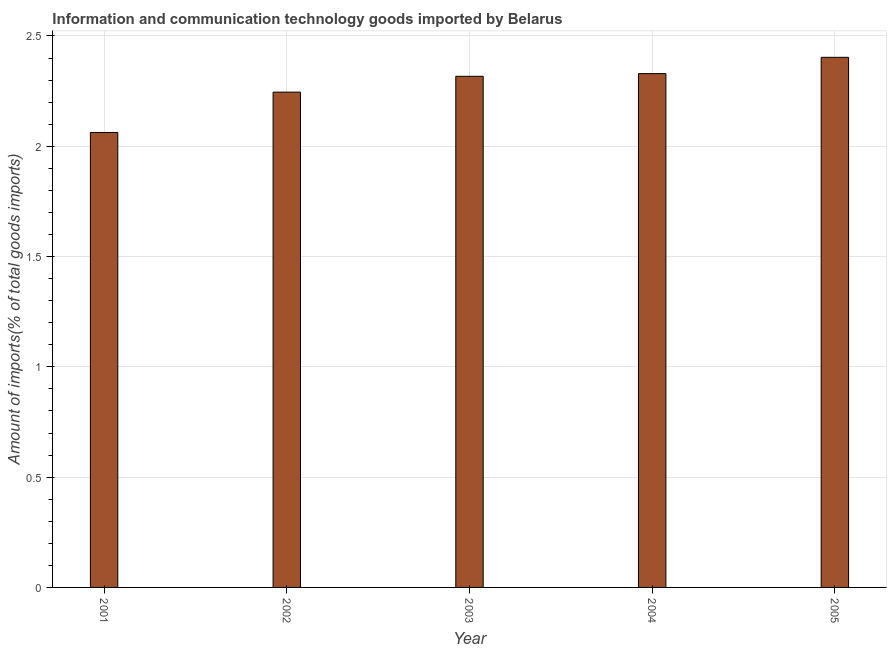Does the graph contain any zero values?
Make the answer very short. No. What is the title of the graph?
Your response must be concise. Information and communication technology goods imported by Belarus. What is the label or title of the X-axis?
Provide a succinct answer. Year. What is the label or title of the Y-axis?
Provide a short and direct response. Amount of imports(% of total goods imports). What is the amount of ict goods imports in 2003?
Offer a very short reply. 2.32. Across all years, what is the maximum amount of ict goods imports?
Keep it short and to the point. 2.4. Across all years, what is the minimum amount of ict goods imports?
Offer a terse response. 2.06. What is the sum of the amount of ict goods imports?
Your answer should be compact. 11.36. What is the difference between the amount of ict goods imports in 2002 and 2004?
Offer a terse response. -0.08. What is the average amount of ict goods imports per year?
Provide a succinct answer. 2.27. What is the median amount of ict goods imports?
Provide a short and direct response. 2.32. Do a majority of the years between 2002 and 2004 (inclusive) have amount of ict goods imports greater than 0.7 %?
Give a very brief answer. Yes. What is the ratio of the amount of ict goods imports in 2004 to that in 2005?
Your response must be concise. 0.97. Is the difference between the amount of ict goods imports in 2002 and 2005 greater than the difference between any two years?
Provide a short and direct response. No. What is the difference between the highest and the second highest amount of ict goods imports?
Your answer should be compact. 0.07. What is the difference between the highest and the lowest amount of ict goods imports?
Ensure brevity in your answer.  0.34. How many bars are there?
Provide a short and direct response. 5. What is the difference between two consecutive major ticks on the Y-axis?
Provide a succinct answer. 0.5. Are the values on the major ticks of Y-axis written in scientific E-notation?
Provide a short and direct response. No. What is the Amount of imports(% of total goods imports) of 2001?
Offer a terse response. 2.06. What is the Amount of imports(% of total goods imports) in 2002?
Ensure brevity in your answer.  2.25. What is the Amount of imports(% of total goods imports) of 2003?
Your answer should be very brief. 2.32. What is the Amount of imports(% of total goods imports) of 2004?
Make the answer very short. 2.33. What is the Amount of imports(% of total goods imports) in 2005?
Provide a short and direct response. 2.4. What is the difference between the Amount of imports(% of total goods imports) in 2001 and 2002?
Ensure brevity in your answer.  -0.18. What is the difference between the Amount of imports(% of total goods imports) in 2001 and 2003?
Your answer should be compact. -0.25. What is the difference between the Amount of imports(% of total goods imports) in 2001 and 2004?
Offer a very short reply. -0.27. What is the difference between the Amount of imports(% of total goods imports) in 2001 and 2005?
Keep it short and to the point. -0.34. What is the difference between the Amount of imports(% of total goods imports) in 2002 and 2003?
Your answer should be very brief. -0.07. What is the difference between the Amount of imports(% of total goods imports) in 2002 and 2004?
Your answer should be very brief. -0.08. What is the difference between the Amount of imports(% of total goods imports) in 2002 and 2005?
Provide a succinct answer. -0.16. What is the difference between the Amount of imports(% of total goods imports) in 2003 and 2004?
Keep it short and to the point. -0.01. What is the difference between the Amount of imports(% of total goods imports) in 2003 and 2005?
Your answer should be very brief. -0.09. What is the difference between the Amount of imports(% of total goods imports) in 2004 and 2005?
Your answer should be very brief. -0.07. What is the ratio of the Amount of imports(% of total goods imports) in 2001 to that in 2002?
Provide a short and direct response. 0.92. What is the ratio of the Amount of imports(% of total goods imports) in 2001 to that in 2003?
Make the answer very short. 0.89. What is the ratio of the Amount of imports(% of total goods imports) in 2001 to that in 2004?
Your answer should be very brief. 0.89. What is the ratio of the Amount of imports(% of total goods imports) in 2001 to that in 2005?
Your response must be concise. 0.86. What is the ratio of the Amount of imports(% of total goods imports) in 2002 to that in 2003?
Offer a terse response. 0.97. What is the ratio of the Amount of imports(% of total goods imports) in 2002 to that in 2004?
Your answer should be compact. 0.96. What is the ratio of the Amount of imports(% of total goods imports) in 2002 to that in 2005?
Give a very brief answer. 0.93. 